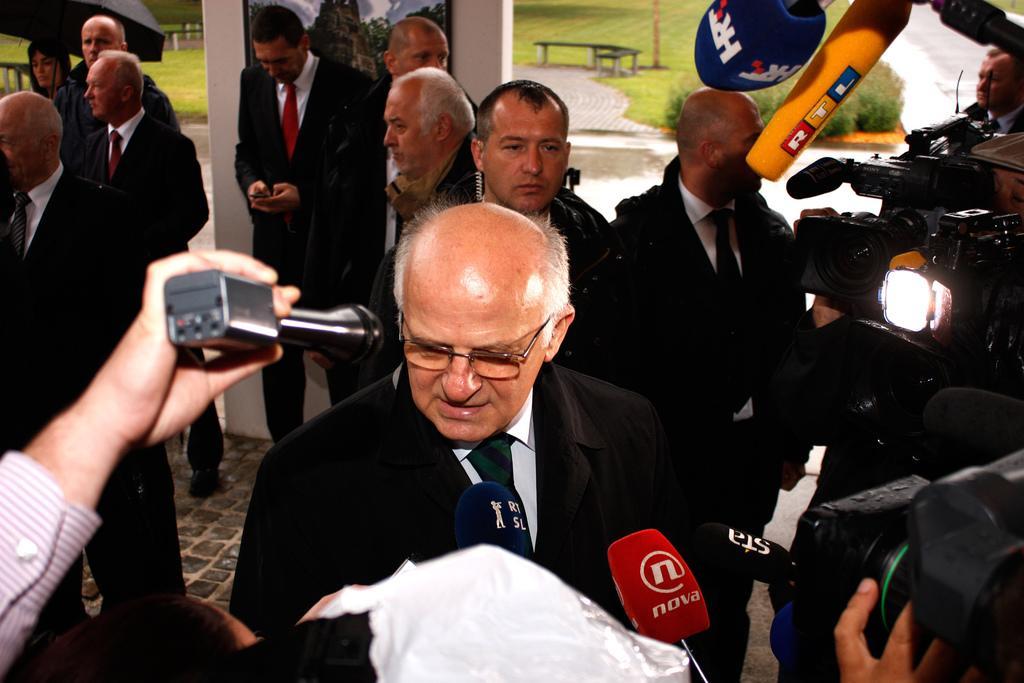Please provide a concise description of this image. In this image we can see a group of persons. In the foreground we can see a person holding a mic. On the right side there are few mice and video cameras. Behind the persons we can see a pillar and on the pillar we can see a photo frame. In the top left, we can see an umbrella. At the top we can see a bench, grass and a group of plants. 